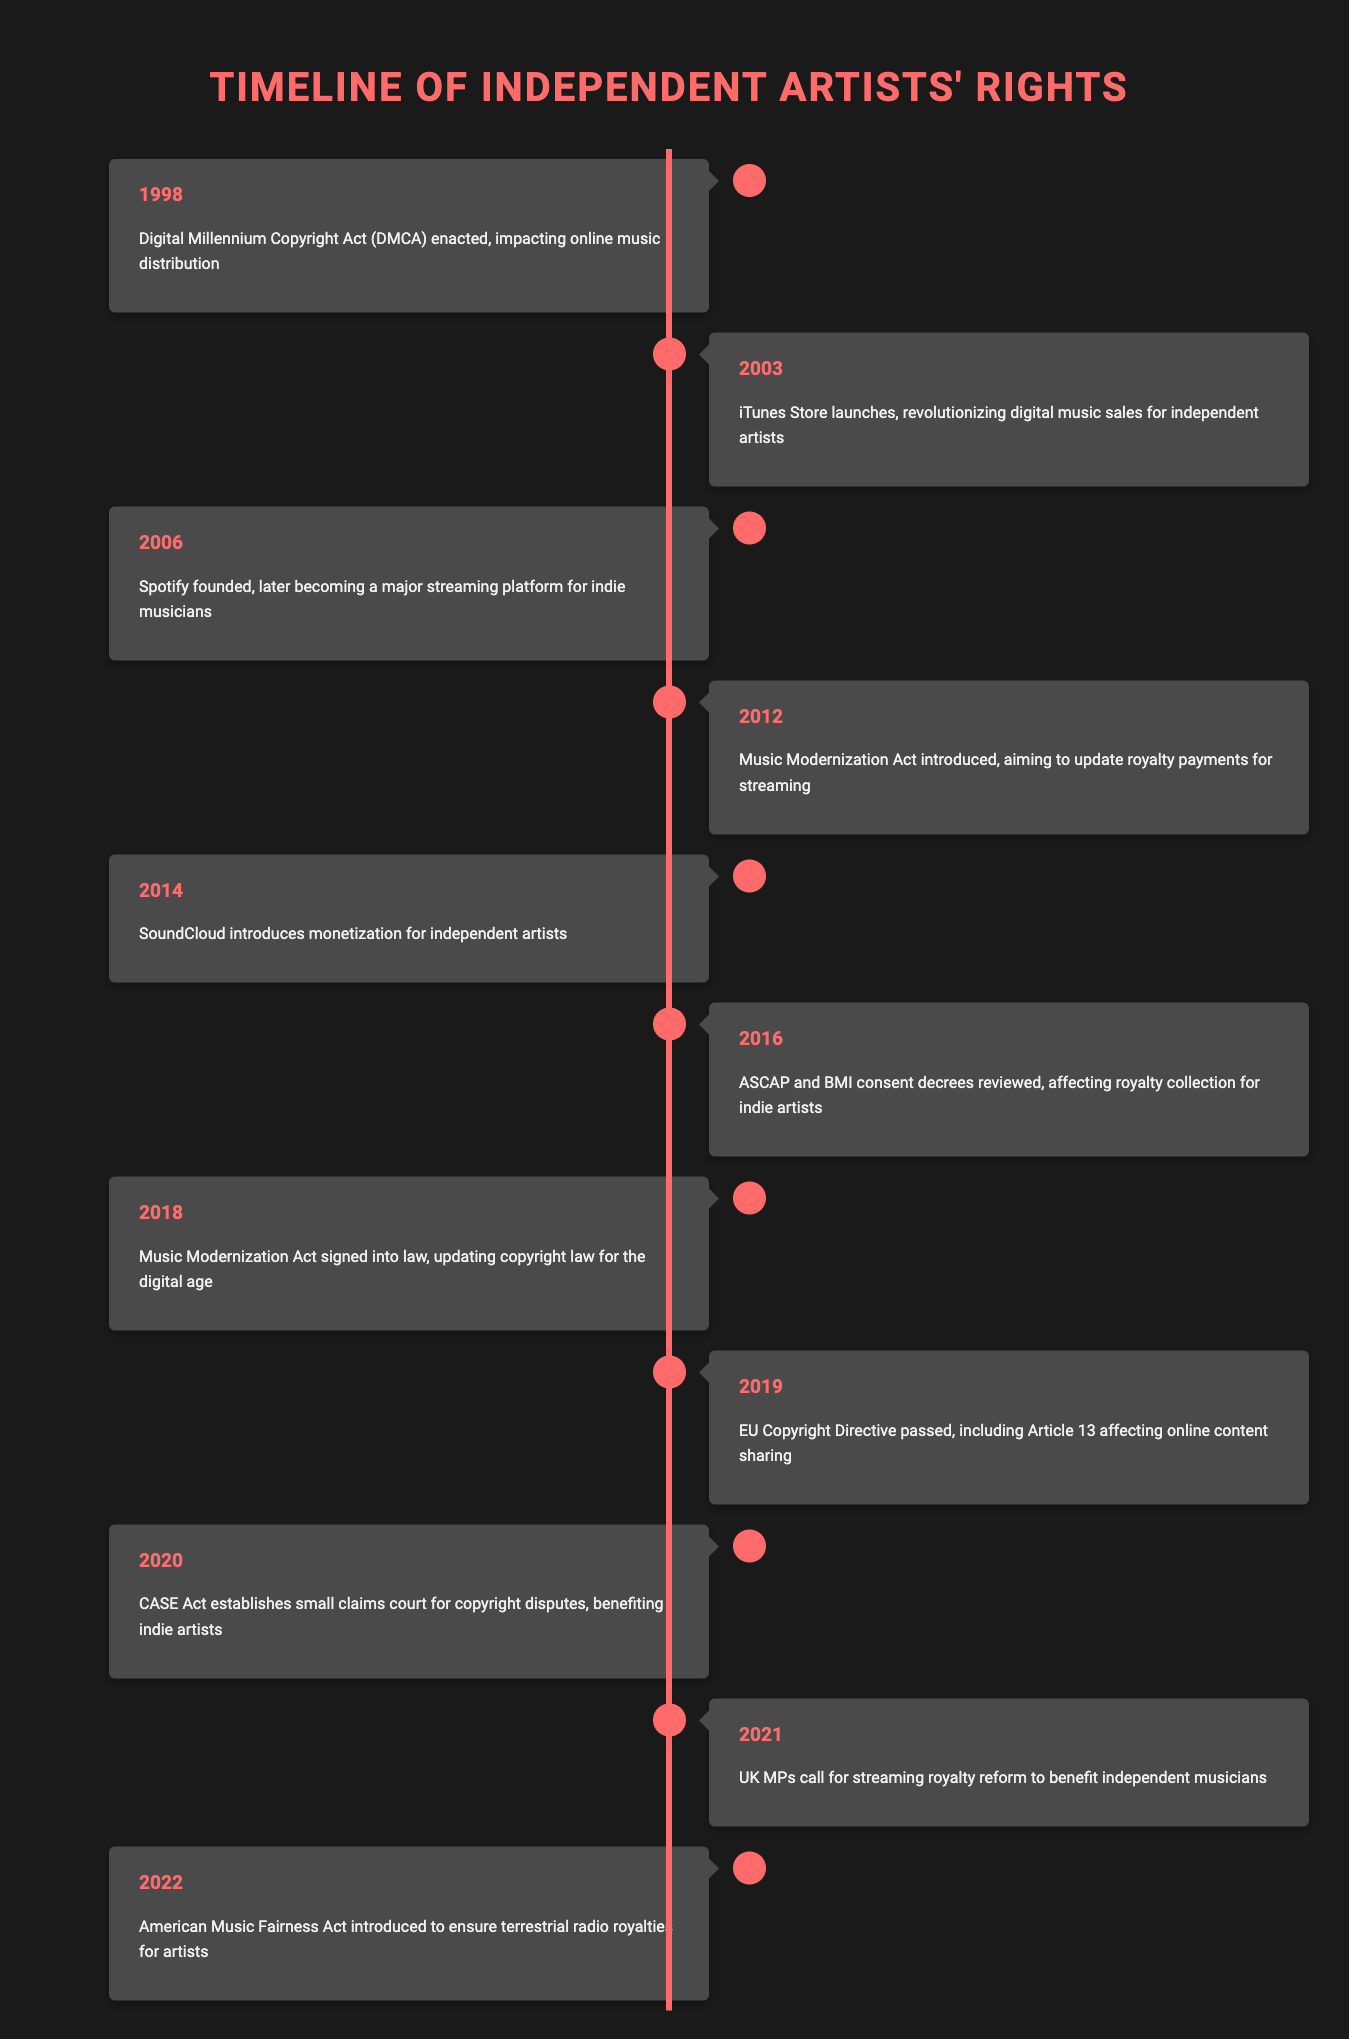What year was the Digital Millennium Copyright Act enacted? The table shows that the Digital Millennium Copyright Act was enacted in the year 1998.
Answer: 1998 Which event took place in 2012? In 2012, the Music Modernization Act was introduced to update royalty payments for streaming, as noted in the timeline.
Answer: Music Modernization Act introduced How many major policy changes affecting independent artists occurred between 2000 and 2010? The years between 2000 and 2010 include three events: 2003 (iTunes Store launches), 2006 (Spotify founded), and 2012 (Music Modernization Act introduced), which means there were two events in this range.
Answer: 2 Did the CASE Act benefit independent artists? Yes, the CASE Act established a small claims court for copyright disputes, which is noted to benefit indie artists.
Answer: Yes What major change happened in the same year as the signing of the Music Modernization Act? The Music Modernization Act was signed in 2018. In the timeline, there is only one event listed for that year, which is the signing of the Music Modernization Act itself. Therefore, it can be concluded that no other major change occurred that year.
Answer: None What is the difference in years between the introduction of the Music Modernization Act in 2012 and its signing into law in 2018? The signing of the Music Modernization Act occurred in 2018, while it was introduced in 2012. The difference is calculated as 2018 - 2012 = 6 years.
Answer: 6 years How many events in the timeline concern the issue of royalties? The events that concern royalties are: 2012 (Music Modernization Act introduced), 2018 (Music Modernization Act signed), 2016 (ASCAP and BMI consent decrees reviewed), 2021 (UK MPs call for streaming royalty reform), and 2022 (American Music Fairness Act introduced). Thus, there are five events related to royalties.
Answer: 5 In which year was SoundCloud's monetization feature introduced for independent artists? The table indicates that SoundCloud introduced monetization for independent artists in 2014.
Answer: 2014 What percentage of the listed events occurred after 2015? There are 11 events listed in total. From 2016 onwards (16, 18, 19, 20, 21, 22), 7 events occurred after 2015. To find the percentage, calculate (7/11) * 100, which equals approximately 63.64%.
Answer: 63.64% 